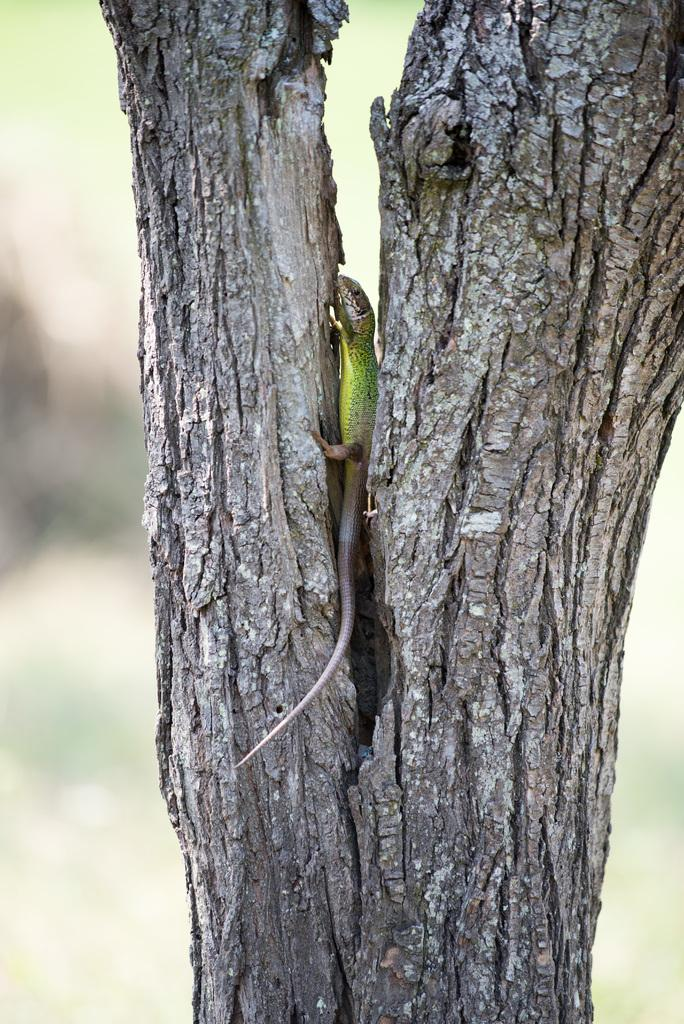What type of animal is in the image? There is a reptile in the image. Where is the reptile located in relation to the tree trunks? The reptile is between the tree trunks. Can you describe the background of the image? The background of the image is blurred. What type of brush is the monkey using to paint the tree trunks in the image? There is no monkey or brush present in the image; it features a reptile between tree trunks with a blurred background. 